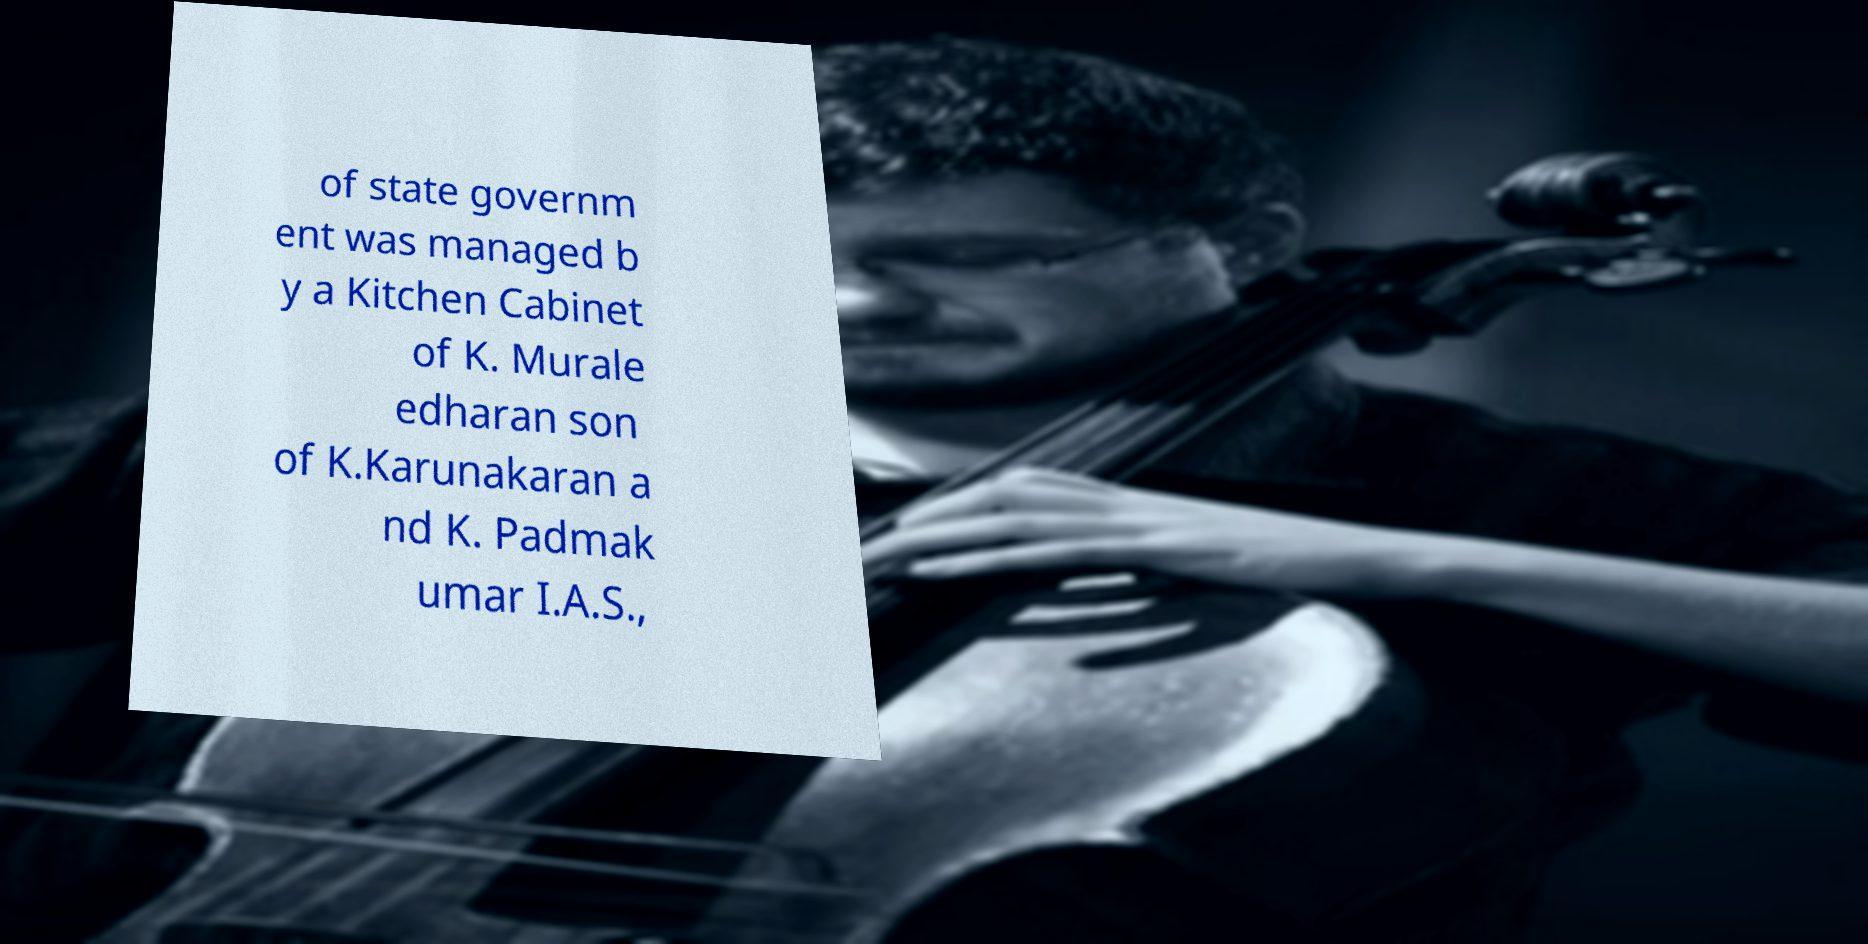There's text embedded in this image that I need extracted. Can you transcribe it verbatim? of state governm ent was managed b y a Kitchen Cabinet of K. Murale edharan son of K.Karunakaran a nd K. Padmak umar I.A.S., 